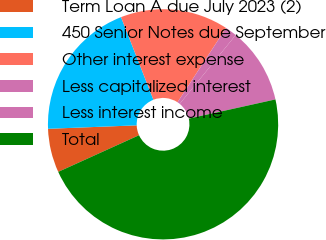Convert chart. <chart><loc_0><loc_0><loc_500><loc_500><pie_chart><fcel>Term Loan A due July 2023 (2)<fcel>450 Senior Notes due September<fcel>Other interest expense<fcel>Less capitalized interest<fcel>Less interest income<fcel>Total<nl><fcel>6.16%<fcel>19.67%<fcel>15.17%<fcel>1.65%<fcel>10.66%<fcel>46.69%<nl></chart> 